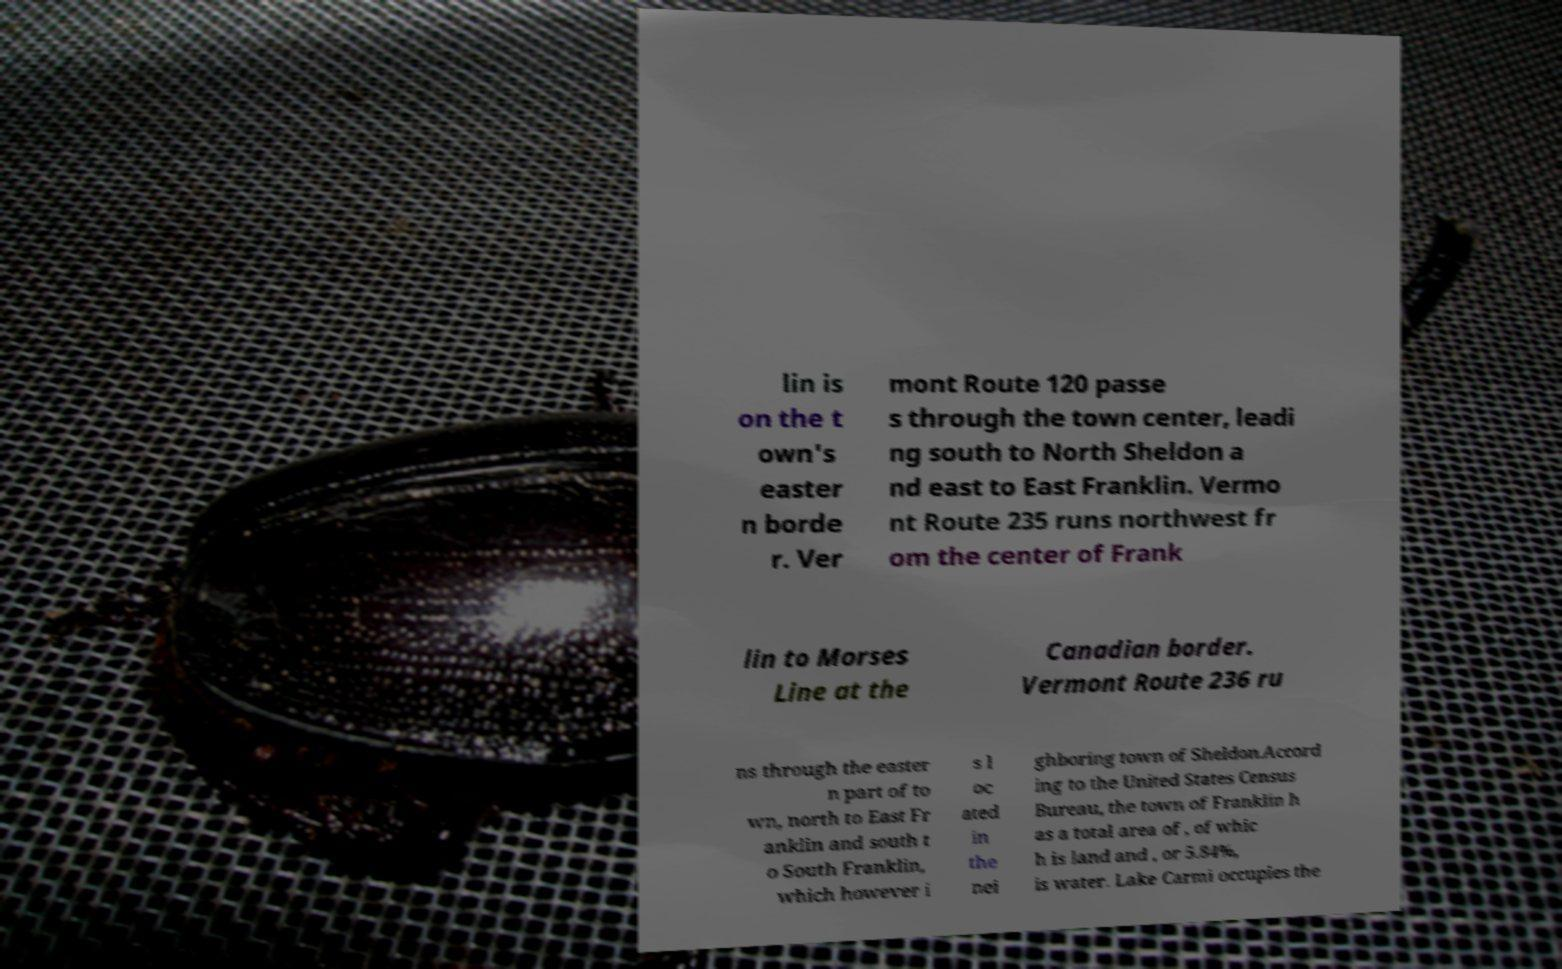I need the written content from this picture converted into text. Can you do that? lin is on the t own's easter n borde r. Ver mont Route 120 passe s through the town center, leadi ng south to North Sheldon a nd east to East Franklin. Vermo nt Route 235 runs northwest fr om the center of Frank lin to Morses Line at the Canadian border. Vermont Route 236 ru ns through the easter n part of to wn, north to East Fr anklin and south t o South Franklin, which however i s l oc ated in the nei ghboring town of Sheldon.Accord ing to the United States Census Bureau, the town of Franklin h as a total area of , of whic h is land and , or 5.84%, is water. Lake Carmi occupies the 